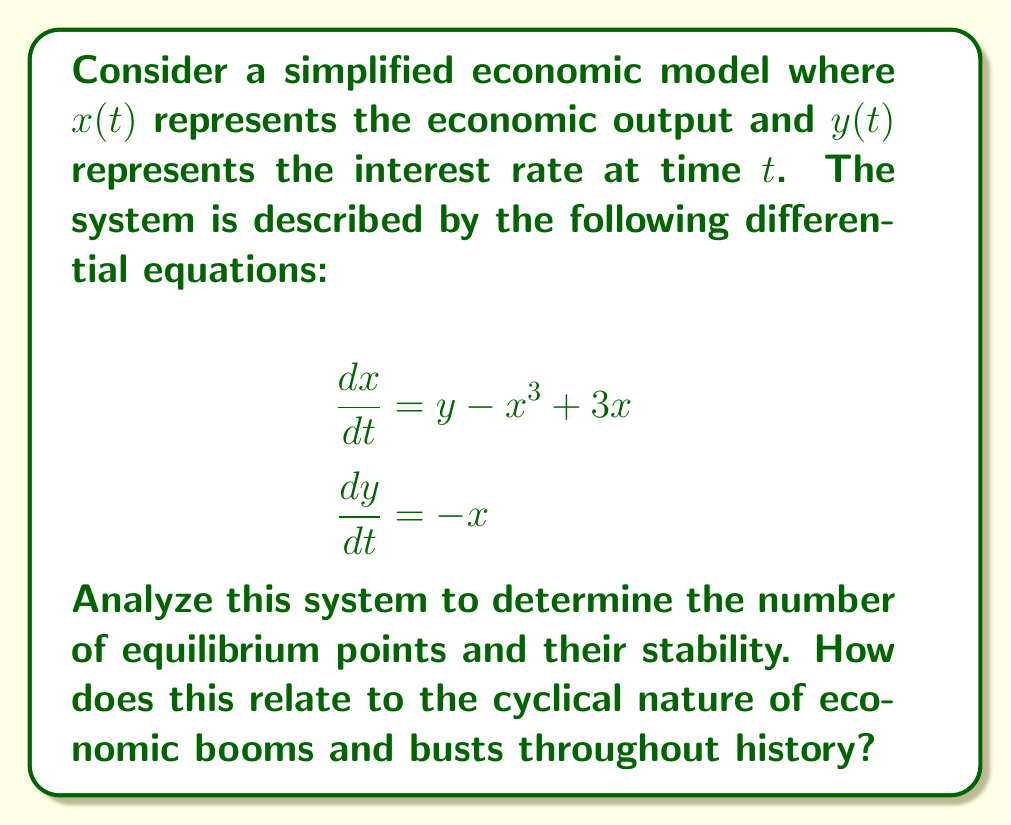Can you answer this question? 1) First, we need to find the equilibrium points by setting both equations to zero:

   $y - x^3 + 3x = 0$
   $-x = 0$

2) From the second equation, we can see that $x = 0$ at equilibrium.

3) Substituting this into the first equation:
   $y + 0 - 0 + 0 = 0$
   Therefore, $y = 0$ at equilibrium.

4) So, $(0,0)$ is an equilibrium point. To check for other equilibrium points, we solve:
   $y - x^3 + 3x = 0$
   $0 - x^3 + 3x = 0$ (since $y = 0$)
   $x(3 - x^2) = 0$
   $x = 0$ or $x = \pm\sqrt{3}$

5) This gives us three equilibrium points: $(0,0)$, $(\sqrt{3},0)$, and $(-\sqrt{3},0)$.

6) To determine stability, we need to find the Jacobian matrix:

   $J = \begin{bmatrix} 
   \frac{\partial}{\partial x}(y - x^3 + 3x) & \frac{\partial}{\partial y}(y - x^3 + 3x) \\
   \frac{\partial}{\partial x}(-x) & \frac{\partial}{\partial y}(-x)
   \end{bmatrix}$

   $J = \begin{bmatrix}
   -3x^2 + 3 & 1 \\
   -1 & 0
   \end{bmatrix}$

7) At $(0,0)$:
   $J_{(0,0)} = \begin{bmatrix}
   3 & 1 \\
   -1 & 0
   \end{bmatrix}$

   The eigenvalues are $\lambda = \frac{3 \pm \sqrt{13}}{2}$. Since both are positive, $(0,0)$ is an unstable node.

8) At $(\sqrt{3},0)$ and $(-\sqrt{3},0)$:
   $J_{(\pm\sqrt{3},0)} = \begin{bmatrix}
   -6 & 1 \\
   -1 & 0
   \end{bmatrix}$

   The eigenvalues are $\lambda = -3 \pm \sqrt{7}i$. These are complex conjugates with negative real parts, so $(\sqrt{3},0)$ and $(-\sqrt{3},0)$ are stable spiral points.

9) The phase plane will show trajectories spiraling into the stable points at $(\sqrt{3},0)$ and $(-\sqrt{3},0)$, representing periods of economic stability. The unstable point at $(0,0)$ represents a tipping point between these two stable states.

This system models the cyclical nature of economic booms and busts. The two stable spiral points represent periods of economic growth (boom) and recession (bust), while the unstable point represents the transition between these states. The spiraling nature of the trajectories reflects the oscillating behavior of economies as they move between growth and recession throughout history.
Answer: 3 equilibrium points: 1 unstable node at (0,0), 2 stable spiral points at $(\pm\sqrt{3},0)$ 